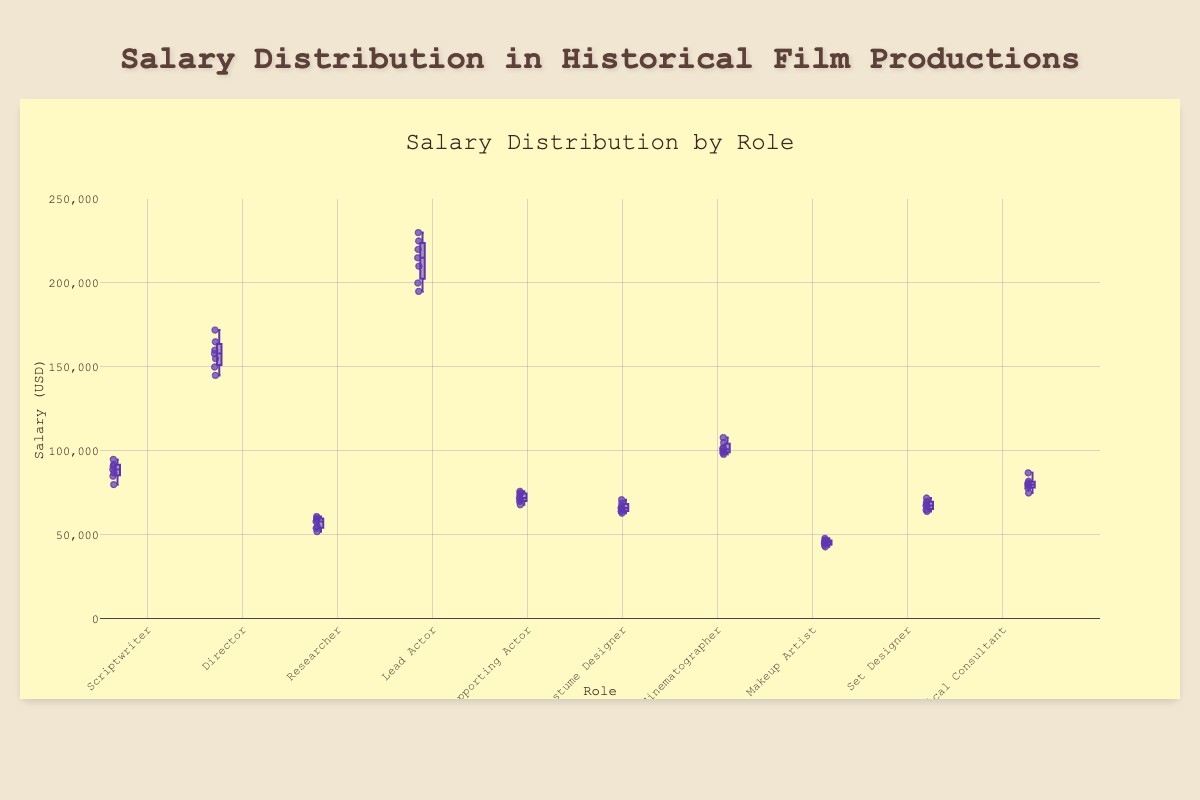What is the highest salary among all roles? The highest salary can be found in the box plot's highest point. The Lead Actor role shows the highest salary among all, which is $230,000.
Answer: $230,000 What is the median salary for the Costume Designer role? The median salary can be found at the line inside the box for the Costume Designer role. The median salary is $66,000.
Answer: $66,000 Which role has the lowest salary range? The role with the lowest salary range can be determined by the smallest box (interquartile range). The Makeup Artist role has the lowest salary range, approximately between $44,000 and $47,000.
Answer: Makeup Artist How do the salaries of Scriptwriters compare to those of Directors? Scriptwriters' salaries range approximately between $80,000 and $95,000, while Directors' salaries range roughly between $145,000 and $172,000. Directors generally have higher salaries compared to Scriptwriters.
Answer: Directors have higher salaries What's the difference between the highest salaries of the Lead Actor and Supporting Actor roles? The highest salary for the Lead Actor is $230,000 and for the Supporting Actor is $76,000. The difference is $230,000 - $76,000 = $154,000.
Answer: $154,000 What is the interquartile range (IQR) for the Researcher role? The interquartile range is the width of the box. For the Researcher role, it spans from roughly $54,000 to $60,000. The IQR is $60,000 - $54,000 = $6,000.
Answer: $6,000 Which roles have outliers in their salary distribution? Outliers are points outside the whiskers of the box plot. No outliers are visible in any roles based on the given description and figures, indicating that all data points fall within the expected range for each role.
Answer: None What's the median salary of the Scriptwriter role compared to the median salary of the Historical Consultant role? The median salary for Scriptwriters is around $89,000, whereas for Historical Consultants it is around $80,000. Therefore, Scriptwriters have a higher median salary compared to Historical Consultants.
Answer: Scriptwriters have a higher median salary What is the range of salaries for the Cinematographer role? The range is determined by the minimum and maximum values for the role. For the Cinematographer, the salaries range from about $98,000 to $108,000.
Answer: $98,000-$108,000 What is the 75th percentile of salaries for the Lead Actor role? The 75th percentile is at the top edge of the box for the Lead Actor role, which shows approximately $225,000.
Answer: $225,000 